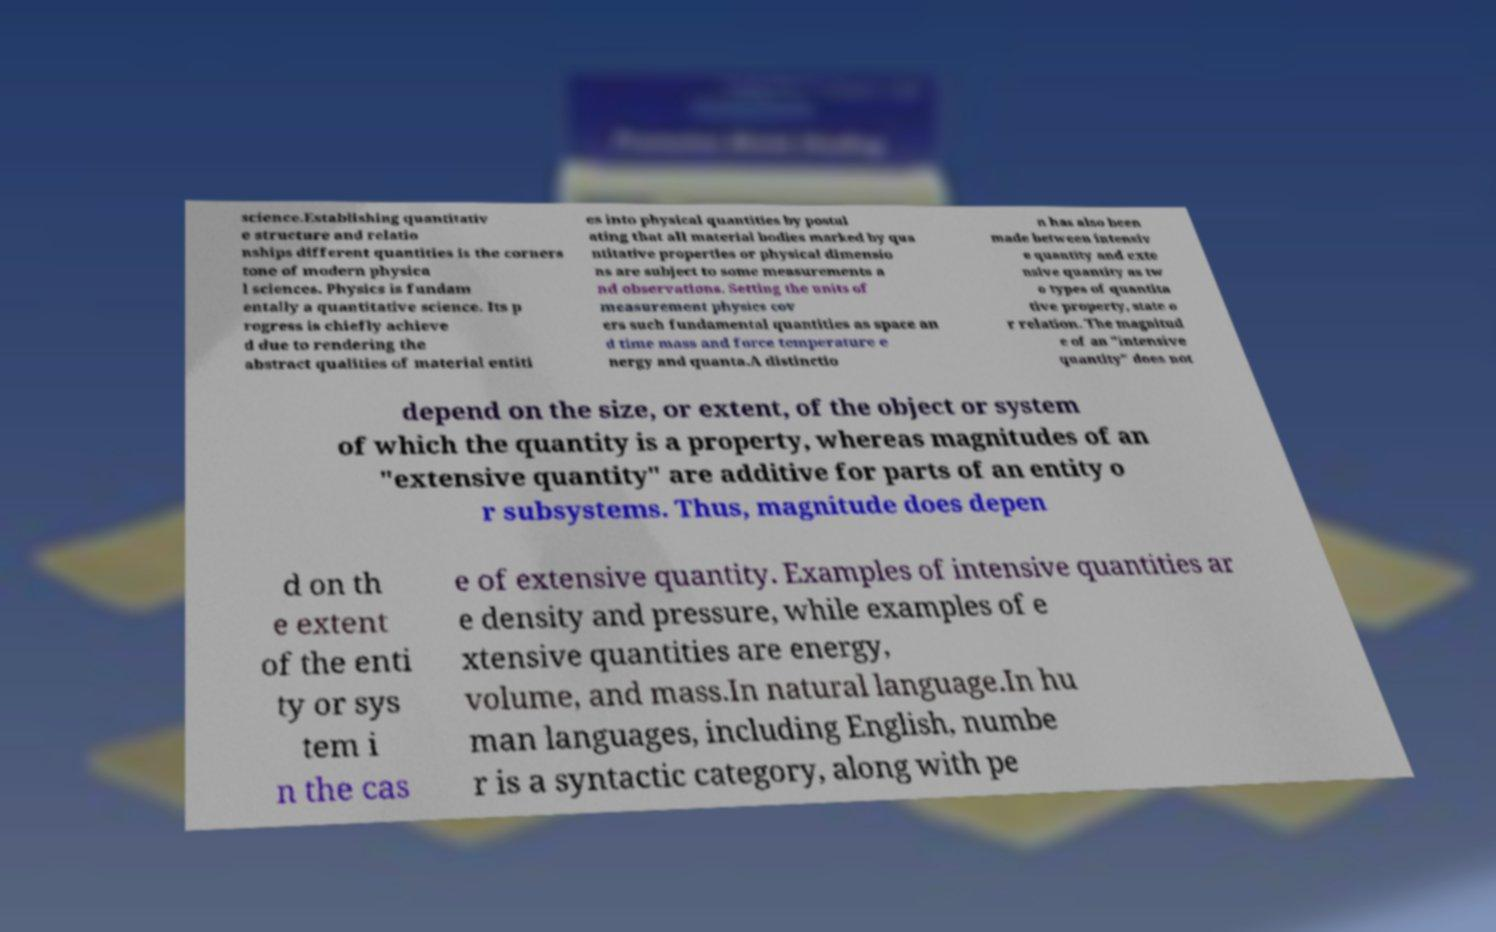Can you accurately transcribe the text from the provided image for me? science.Establishing quantitativ e structure and relatio nships different quantities is the corners tone of modern physica l sciences. Physics is fundam entally a quantitative science. Its p rogress is chiefly achieve d due to rendering the abstract qualities of material entiti es into physical quantities by postul ating that all material bodies marked by qua ntitative properties or physical dimensio ns are subject to some measurements a nd observations. Setting the units of measurement physics cov ers such fundamental quantities as space an d time mass and force temperature e nergy and quanta.A distinctio n has also been made between intensiv e quantity and exte nsive quantity as tw o types of quantita tive property, state o r relation. The magnitud e of an "intensive quantity" does not depend on the size, or extent, of the object or system of which the quantity is a property, whereas magnitudes of an "extensive quantity" are additive for parts of an entity o r subsystems. Thus, magnitude does depen d on th e extent of the enti ty or sys tem i n the cas e of extensive quantity. Examples of intensive quantities ar e density and pressure, while examples of e xtensive quantities are energy, volume, and mass.In natural language.In hu man languages, including English, numbe r is a syntactic category, along with pe 